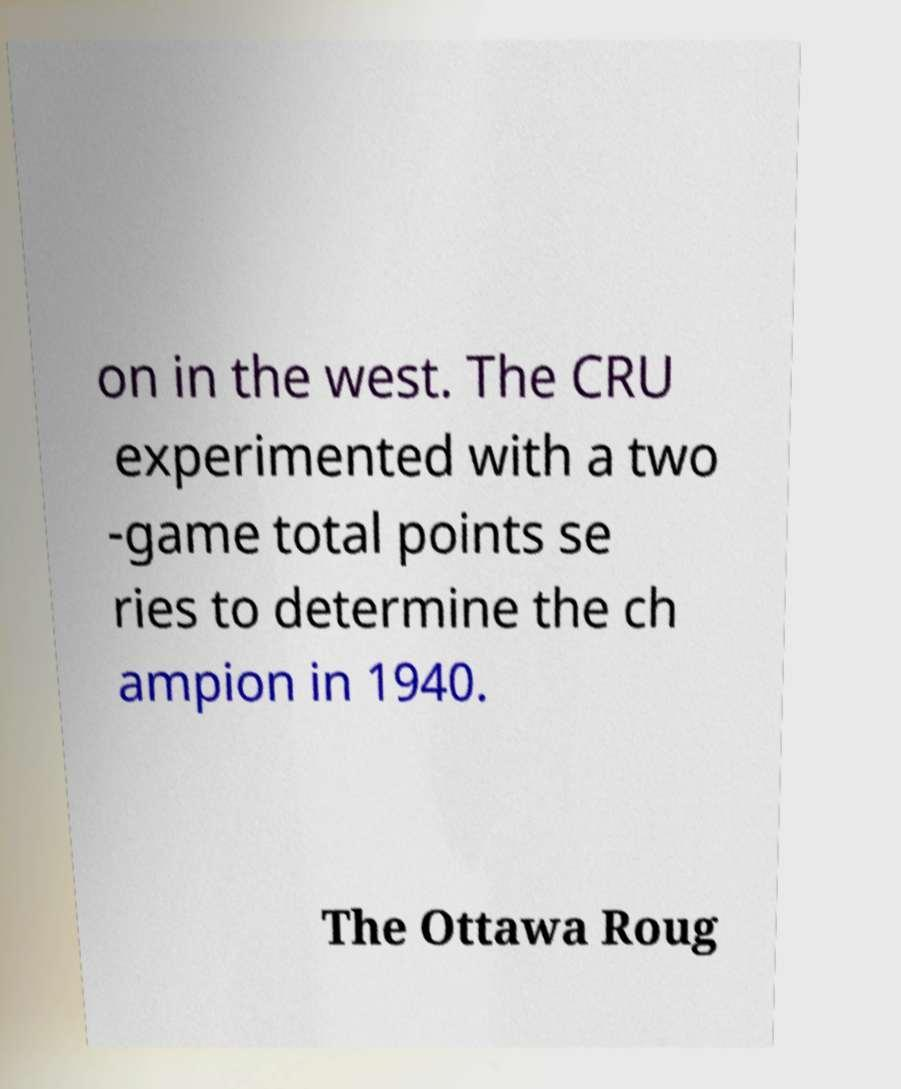Please identify and transcribe the text found in this image. on in the west. The CRU experimented with a two -game total points se ries to determine the ch ampion in 1940. The Ottawa Roug 